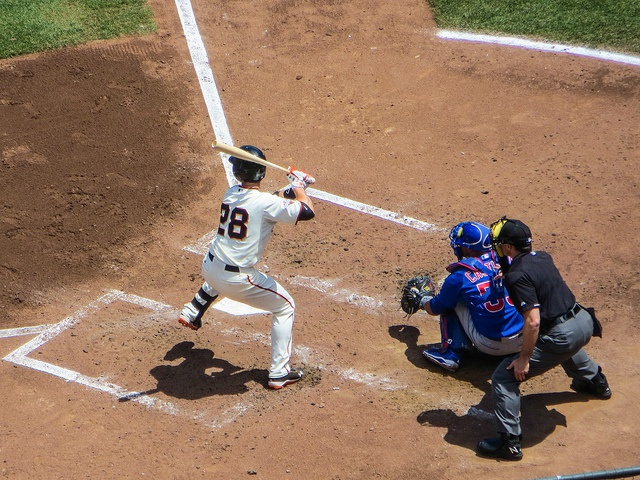Describe the objects in this image and their specific colors. I can see people in green, darkgray, lightgray, black, and tan tones, people in green, black, gray, and maroon tones, people in green, black, navy, gray, and blue tones, baseball glove in green, black, gray, darkgray, and tan tones, and baseball bat in green, beige, tan, and gray tones in this image. 